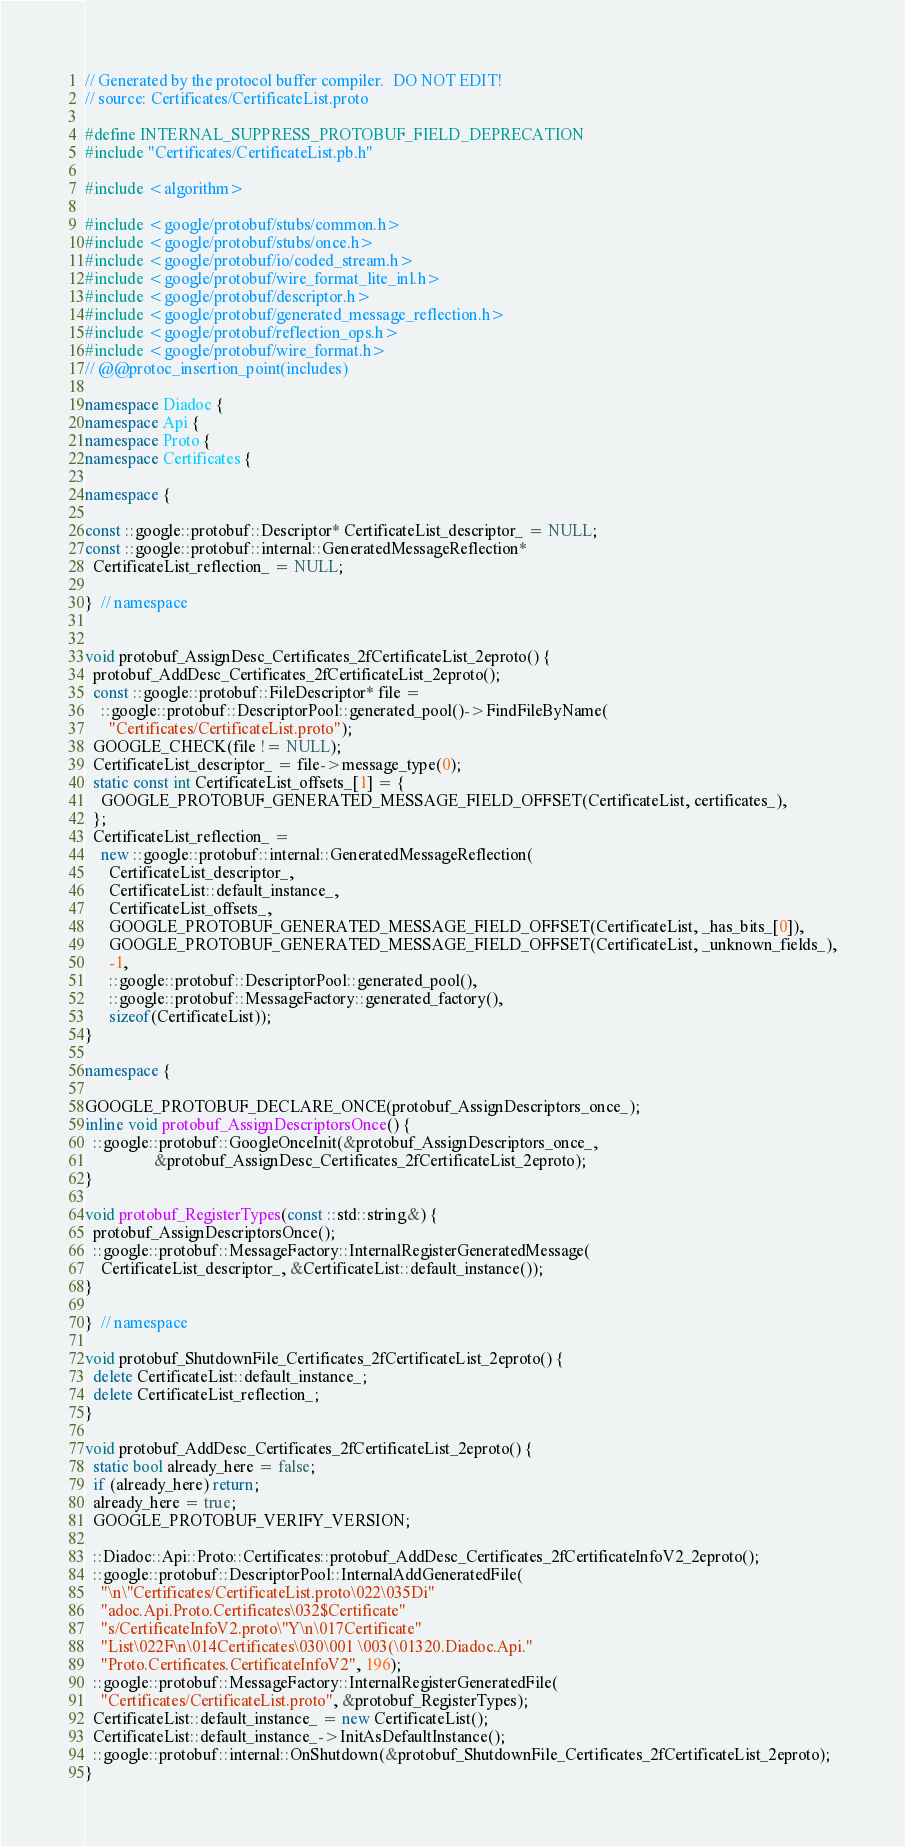<code> <loc_0><loc_0><loc_500><loc_500><_C++_>// Generated by the protocol buffer compiler.  DO NOT EDIT!
// source: Certificates/CertificateList.proto

#define INTERNAL_SUPPRESS_PROTOBUF_FIELD_DEPRECATION
#include "Certificates/CertificateList.pb.h"

#include <algorithm>

#include <google/protobuf/stubs/common.h>
#include <google/protobuf/stubs/once.h>
#include <google/protobuf/io/coded_stream.h>
#include <google/protobuf/wire_format_lite_inl.h>
#include <google/protobuf/descriptor.h>
#include <google/protobuf/generated_message_reflection.h>
#include <google/protobuf/reflection_ops.h>
#include <google/protobuf/wire_format.h>
// @@protoc_insertion_point(includes)

namespace Diadoc {
namespace Api {
namespace Proto {
namespace Certificates {

namespace {

const ::google::protobuf::Descriptor* CertificateList_descriptor_ = NULL;
const ::google::protobuf::internal::GeneratedMessageReflection*
  CertificateList_reflection_ = NULL;

}  // namespace


void protobuf_AssignDesc_Certificates_2fCertificateList_2eproto() {
  protobuf_AddDesc_Certificates_2fCertificateList_2eproto();
  const ::google::protobuf::FileDescriptor* file =
    ::google::protobuf::DescriptorPool::generated_pool()->FindFileByName(
      "Certificates/CertificateList.proto");
  GOOGLE_CHECK(file != NULL);
  CertificateList_descriptor_ = file->message_type(0);
  static const int CertificateList_offsets_[1] = {
    GOOGLE_PROTOBUF_GENERATED_MESSAGE_FIELD_OFFSET(CertificateList, certificates_),
  };
  CertificateList_reflection_ =
    new ::google::protobuf::internal::GeneratedMessageReflection(
      CertificateList_descriptor_,
      CertificateList::default_instance_,
      CertificateList_offsets_,
      GOOGLE_PROTOBUF_GENERATED_MESSAGE_FIELD_OFFSET(CertificateList, _has_bits_[0]),
      GOOGLE_PROTOBUF_GENERATED_MESSAGE_FIELD_OFFSET(CertificateList, _unknown_fields_),
      -1,
      ::google::protobuf::DescriptorPool::generated_pool(),
      ::google::protobuf::MessageFactory::generated_factory(),
      sizeof(CertificateList));
}

namespace {

GOOGLE_PROTOBUF_DECLARE_ONCE(protobuf_AssignDescriptors_once_);
inline void protobuf_AssignDescriptorsOnce() {
  ::google::protobuf::GoogleOnceInit(&protobuf_AssignDescriptors_once_,
                 &protobuf_AssignDesc_Certificates_2fCertificateList_2eproto);
}

void protobuf_RegisterTypes(const ::std::string&) {
  protobuf_AssignDescriptorsOnce();
  ::google::protobuf::MessageFactory::InternalRegisterGeneratedMessage(
    CertificateList_descriptor_, &CertificateList::default_instance());
}

}  // namespace

void protobuf_ShutdownFile_Certificates_2fCertificateList_2eproto() {
  delete CertificateList::default_instance_;
  delete CertificateList_reflection_;
}

void protobuf_AddDesc_Certificates_2fCertificateList_2eproto() {
  static bool already_here = false;
  if (already_here) return;
  already_here = true;
  GOOGLE_PROTOBUF_VERIFY_VERSION;

  ::Diadoc::Api::Proto::Certificates::protobuf_AddDesc_Certificates_2fCertificateInfoV2_2eproto();
  ::google::protobuf::DescriptorPool::InternalAddGeneratedFile(
    "\n\"Certificates/CertificateList.proto\022\035Di"
    "adoc.Api.Proto.Certificates\032$Certificate"
    "s/CertificateInfoV2.proto\"Y\n\017Certificate"
    "List\022F\n\014Certificates\030\001 \003(\01320.Diadoc.Api."
    "Proto.Certificates.CertificateInfoV2", 196);
  ::google::protobuf::MessageFactory::InternalRegisterGeneratedFile(
    "Certificates/CertificateList.proto", &protobuf_RegisterTypes);
  CertificateList::default_instance_ = new CertificateList();
  CertificateList::default_instance_->InitAsDefaultInstance();
  ::google::protobuf::internal::OnShutdown(&protobuf_ShutdownFile_Certificates_2fCertificateList_2eproto);
}
</code> 